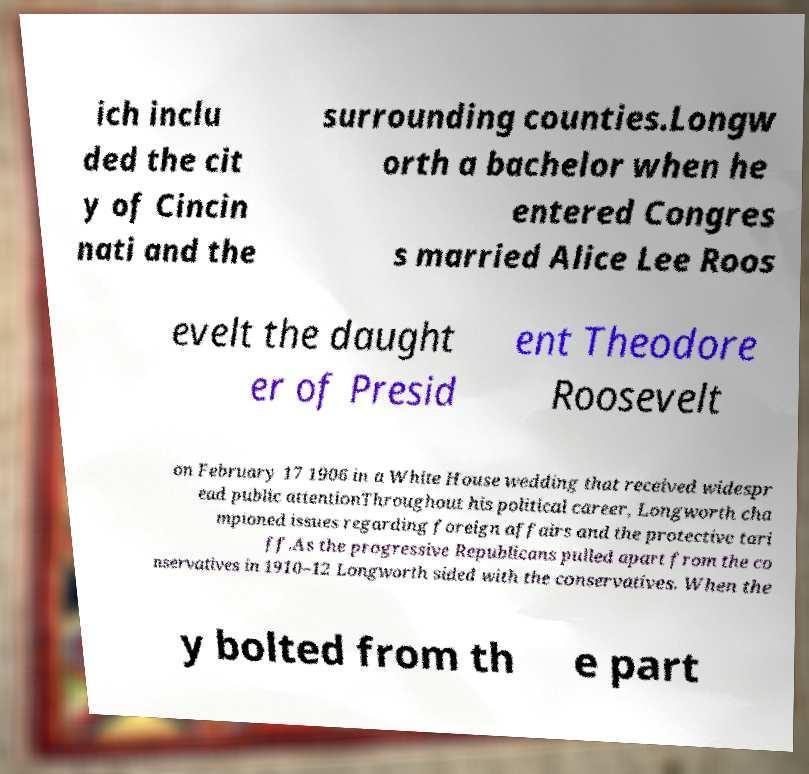Please identify and transcribe the text found in this image. ich inclu ded the cit y of Cincin nati and the surrounding counties.Longw orth a bachelor when he entered Congres s married Alice Lee Roos evelt the daught er of Presid ent Theodore Roosevelt on February 17 1906 in a White House wedding that received widespr ead public attentionThroughout his political career, Longworth cha mpioned issues regarding foreign affairs and the protective tari ff.As the progressive Republicans pulled apart from the co nservatives in 1910–12 Longworth sided with the conservatives. When the y bolted from th e part 